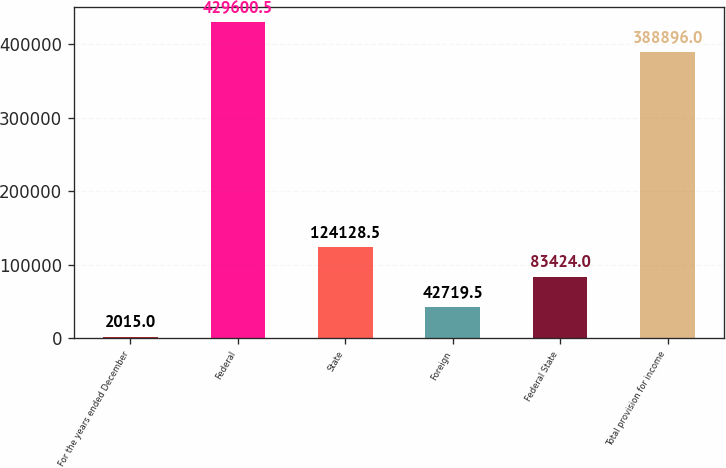Convert chart to OTSL. <chart><loc_0><loc_0><loc_500><loc_500><bar_chart><fcel>For the years ended December<fcel>Federal<fcel>State<fcel>Foreign<fcel>Federal State<fcel>Total provision for income<nl><fcel>2015<fcel>429600<fcel>124128<fcel>42719.5<fcel>83424<fcel>388896<nl></chart> 